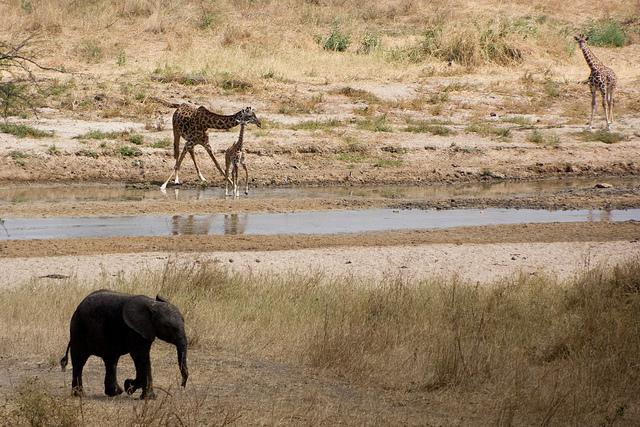What animal is in the water?
Quick response, please. Giraffe. Is this a shaded area?
Give a very brief answer. No. How many animals are there?
Answer briefly. 4. Is there an elephant?
Keep it brief. Yes. Is there a baby giraffe?
Quick response, please. Yes. 